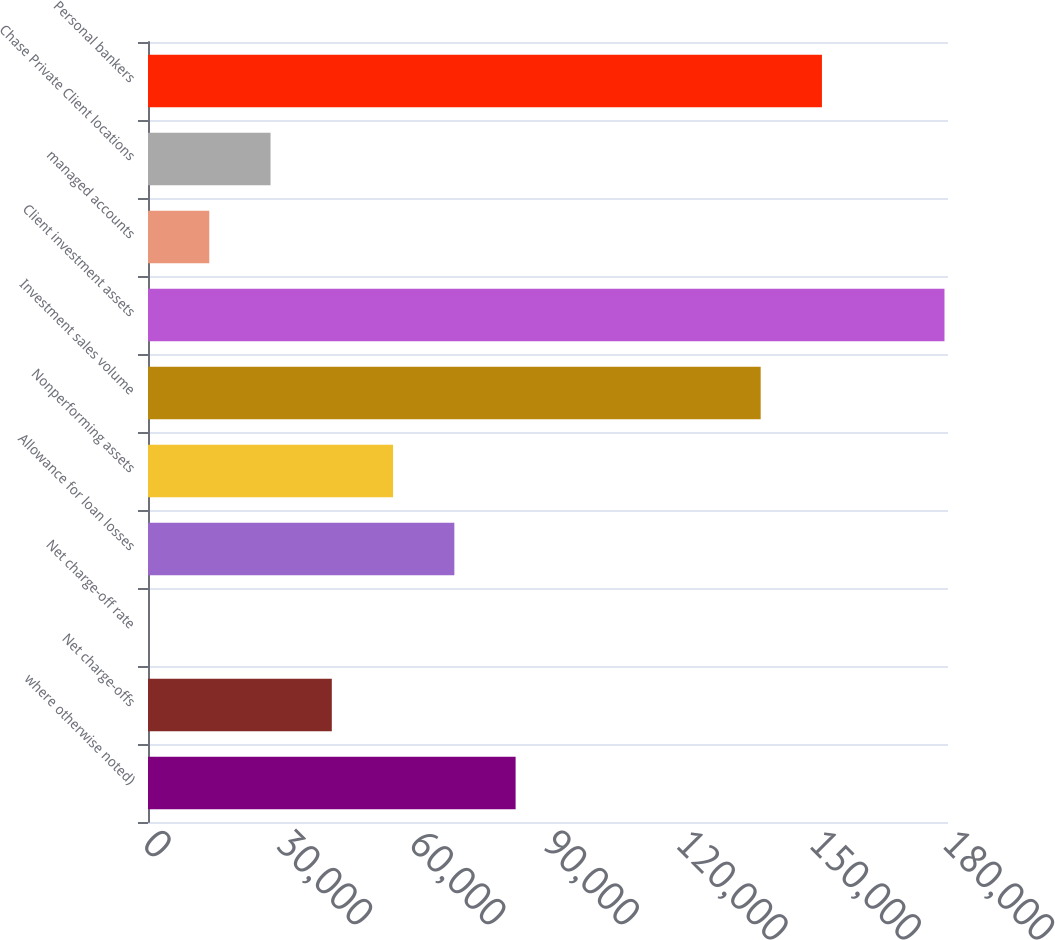Convert chart to OTSL. <chart><loc_0><loc_0><loc_500><loc_500><bar_chart><fcel>where otherwise noted)<fcel>Net charge-offs<fcel>Net charge-off rate<fcel>Allowance for loan losses<fcel>Nonperforming assets<fcel>Investment sales volume<fcel>Client investment assets<fcel>managed accounts<fcel>Chase Private Client locations<fcel>Personal bankers<nl><fcel>82712.9<fcel>41357.9<fcel>2.89<fcel>68927.9<fcel>55142.9<fcel>137853<fcel>179208<fcel>13787.9<fcel>27572.9<fcel>151638<nl></chart> 